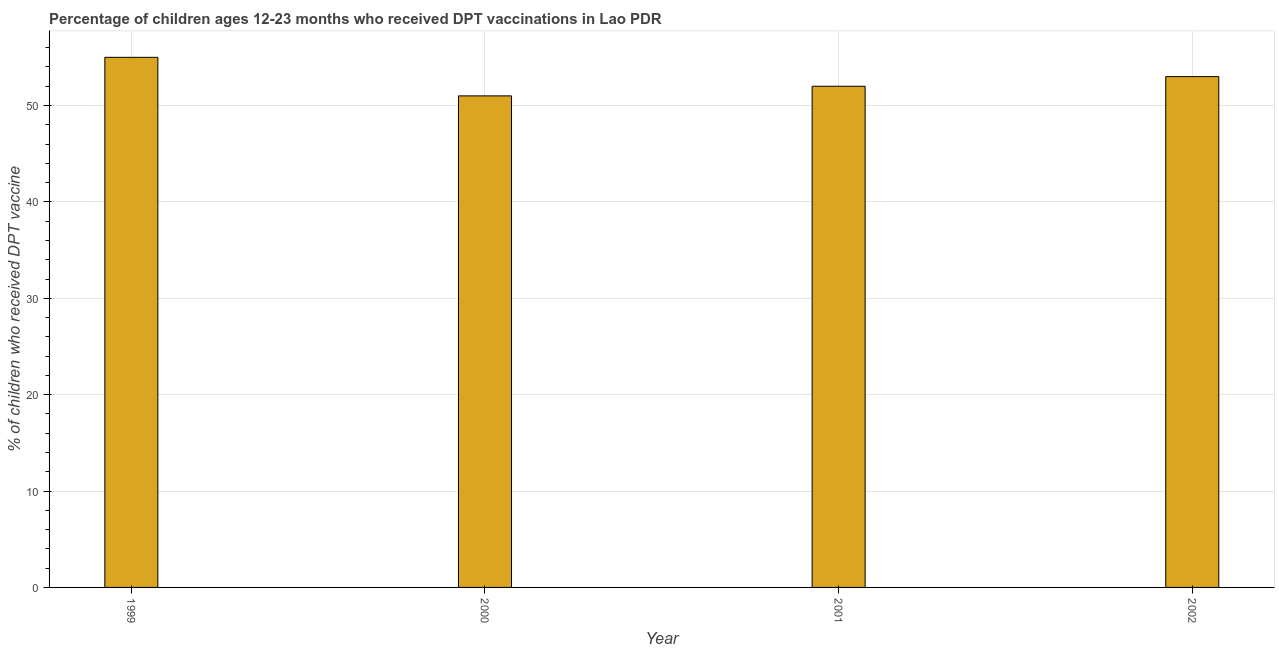Does the graph contain any zero values?
Your response must be concise. No. What is the title of the graph?
Make the answer very short. Percentage of children ages 12-23 months who received DPT vaccinations in Lao PDR. What is the label or title of the Y-axis?
Give a very brief answer. % of children who received DPT vaccine. Across all years, what is the maximum percentage of children who received dpt vaccine?
Your response must be concise. 55. Across all years, what is the minimum percentage of children who received dpt vaccine?
Keep it short and to the point. 51. In which year was the percentage of children who received dpt vaccine minimum?
Your answer should be compact. 2000. What is the sum of the percentage of children who received dpt vaccine?
Ensure brevity in your answer.  211. What is the difference between the percentage of children who received dpt vaccine in 2000 and 2002?
Offer a very short reply. -2. What is the average percentage of children who received dpt vaccine per year?
Your response must be concise. 52. What is the median percentage of children who received dpt vaccine?
Keep it short and to the point. 52.5. What is the ratio of the percentage of children who received dpt vaccine in 2000 to that in 2001?
Your answer should be very brief. 0.98. In how many years, is the percentage of children who received dpt vaccine greater than the average percentage of children who received dpt vaccine taken over all years?
Offer a very short reply. 2. How many bars are there?
Your answer should be compact. 4. Are all the bars in the graph horizontal?
Offer a very short reply. No. Are the values on the major ticks of Y-axis written in scientific E-notation?
Keep it short and to the point. No. What is the % of children who received DPT vaccine in 2000?
Offer a terse response. 51. What is the difference between the % of children who received DPT vaccine in 1999 and 2000?
Give a very brief answer. 4. What is the difference between the % of children who received DPT vaccine in 1999 and 2001?
Provide a succinct answer. 3. What is the difference between the % of children who received DPT vaccine in 1999 and 2002?
Ensure brevity in your answer.  2. What is the difference between the % of children who received DPT vaccine in 2000 and 2002?
Your response must be concise. -2. What is the ratio of the % of children who received DPT vaccine in 1999 to that in 2000?
Keep it short and to the point. 1.08. What is the ratio of the % of children who received DPT vaccine in 1999 to that in 2001?
Your answer should be very brief. 1.06. What is the ratio of the % of children who received DPT vaccine in 1999 to that in 2002?
Provide a short and direct response. 1.04. What is the ratio of the % of children who received DPT vaccine in 2000 to that in 2001?
Offer a terse response. 0.98. What is the ratio of the % of children who received DPT vaccine in 2000 to that in 2002?
Make the answer very short. 0.96. 